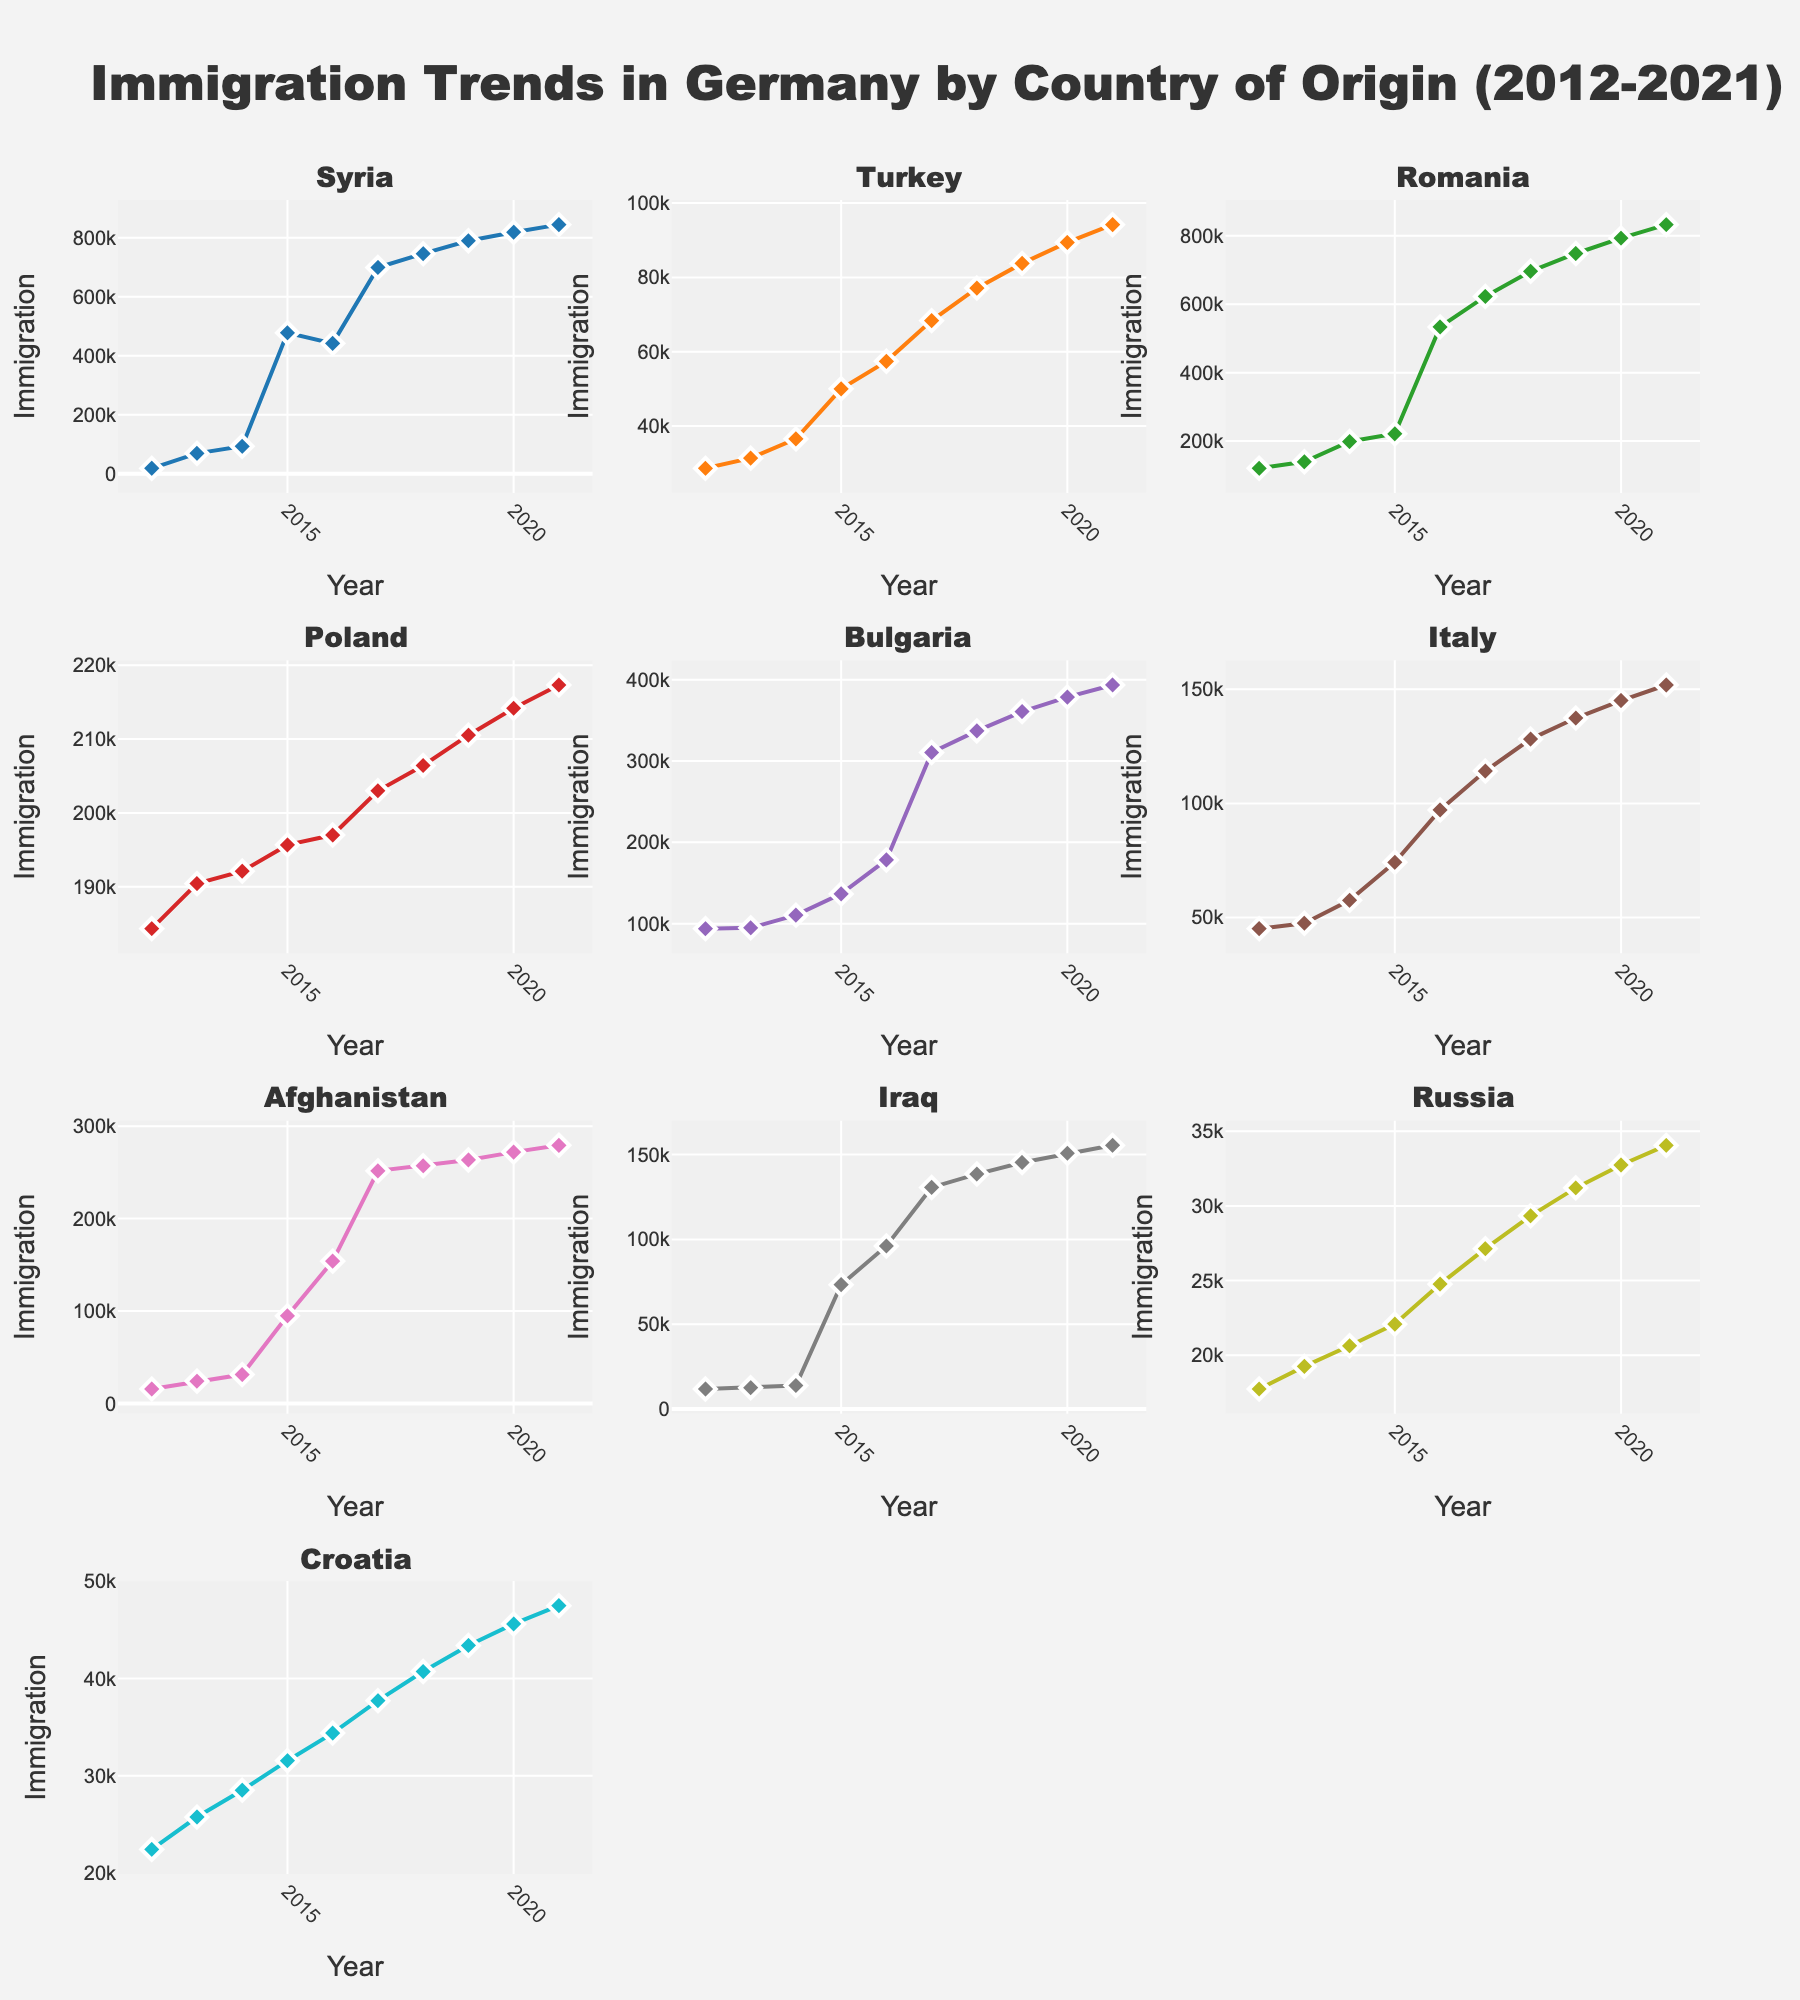What is the title of the figure? The title is located at the top of the figure. It is "Immigration Trends in Germany by Country of Origin (2012-2021)."
Answer: Immigration Trends in Germany by Country of Origin (2012-2021) How many years of data are presented in the figure? The x-axis in each subplot represents the years, ranging from 2012 to 2021, which means there are 10 years of data presented.
Answer: 10 years Which country had the highest immigration to Germany in 2017? In the 2017 subplot, the highest point is observed in the chart for Syria, indicating Syria had the highest immigration in that year.
Answer: Syria In which year did Turkey experience the highest immigration to Germany? By examining the Turkey subplot and identifying the highest point, we see that the peak immigration for Turkey occurred in 2020.
Answer: 2020 What is the visible trend in immigration from Afghanistan to Germany from 2012 to 2021? Observing the Afghanistan subplot, there is a clear upward trend, showing an increase in immigration from 2012 to 2021.
Answer: Increasing trend Between Syria and Romania, which country had a higher immigration in 2015? By comparing the data points in the Syria and Romania subplots for the year 2015, it is evident that Syria had significantly higher immigration than Romania.
Answer: Syria How does immigration from Poland compare to immigration from Bulgaria in 2016? In 2016, the data points on the Poland subplot are lower than those on the Bulgaria subplot, indicating that Bulgaria had higher immigration to Germany than Poland in that year.
Answer: Bulgaria What is the difference in immigration figures between Iraq and Croatia in 2021? In the 2021 data point on the Iraq subplot, immigration is approximately 155,450, and in the Croatia subplot, it is around 47,485. The difference is 155,450 - 47,485 = 107,965.
Answer: 107,965 What are the colors used for the Syria and Russia subplots? Each subplot is color-coded, with Syria represented in a distinct color (blue) and Russia also in its own color (light blue).
Answer: Syria: blue, Russia: light blue Which country shows the most stable immigration trend over the decade? The subplot for Turkey shows relatively stable immigration numbers compared to other countries, indicating Turkey had the most stable trend.
Answer: Turkey 